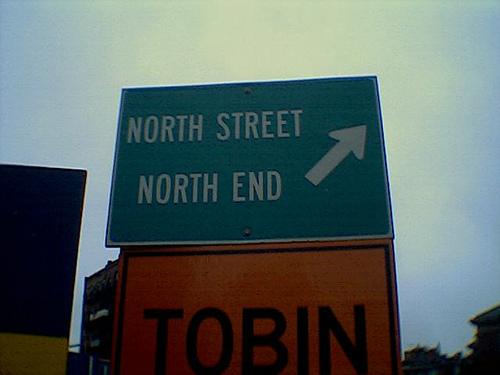Which direction are the signs pointing?
Short answer required. Right. What does the sign say?
Give a very brief answer. North street north end. What direction is the arrow pointing?
Short answer required. Right. What is the sign saying?
Write a very short answer. North street north end. Is it light outside?
Concise answer only. Yes. What is the history of the sign in this photo?
Concise answer only. Unknown. What do the signs say?
Write a very short answer. North street north end tobin. What is a driver supposed to do when they see this sign?
Short answer required. Go right. What kind of sign is that?
Concise answer only. Street. Is the arrow a ring?
Quick response, please. No. What does the top word on the sign say?
Write a very short answer. North street. How many stop signs are there?
Concise answer only. 0. What language is the signs written in?
Short answer required. English. What direction is the arrow pointing towards?
Quick response, please. Right. Does the black and yellow symbol mean caution?
Short answer required. Yes. What color is the arrow?
Give a very brief answer. White. Is this sign old?
Concise answer only. No. What color is the sign?
Short answer required. Green. What corner is this?
Answer briefly. North. Where exactly is Tobin?
Short answer required. North street. What is the arrow directing you to?
Answer briefly. North street. 